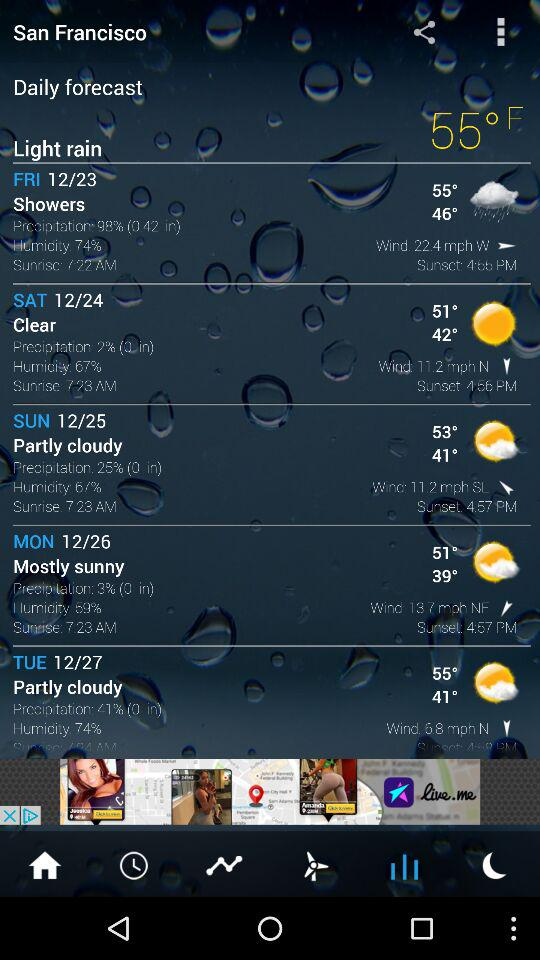What is the time of sunrise on Saturday? The time of sunrise on Saturday is 7:23 AM. 